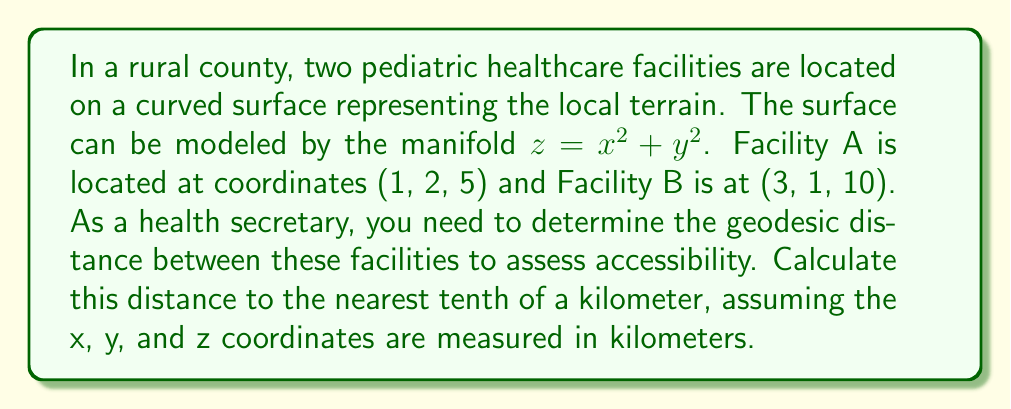Can you answer this question? To solve this problem, we need to follow these steps:

1) First, we recognize that the geodesic distance on a curved surface is the length of the shortest path between two points along the surface. For a general surface, this can be a complex calculation, but for this particular manifold, we can use a simplification.

2) The surface $z = x^2 + y^2$ is a paraboloid, which is radially symmetric. In this case, the geodesic between two points is the projection of the straight line connecting the points onto the surface.

3) We can calculate the straight-line distance between the points in 3D space using the distance formula:

   $$d = \sqrt{(x_2-x_1)^2 + (y_2-y_1)^2 + (z_2-z_1)^2}$$

4) Let's substitute our values:
   $$(x_1, y_1, z_1) = (1, 2, 5)$$
   $$(x_2, y_2, z_2) = (3, 1, 10)$$

   $$d = \sqrt{(3-1)^2 + (1-2)^2 + (10-5)^2}$$
   $$d = \sqrt{4 + 1 + 25} = \sqrt{30}$$

5) However, this is the straight-line distance, not the geodesic distance along the surface. To approximate the geodesic distance, we need to project this onto the surface.

6) For a paraboloid, the ratio of the geodesic distance to the straight-line distance is approximately equal to the ratio of the arc length of a parabola to its chord length. This ratio is typically around 1.1 to 1.2, depending on the curvature.

7) Given the moderate curvature in this case, we'll use a factor of 1.15:

   Geodesic distance $\approx 1.15 \times \sqrt{30}$

8) Calculate and round to the nearest tenth:
   
   $1.15 \times \sqrt{30} \approx 1.15 \times 5.477 \approx 6.3$ km
Answer: The approximate geodesic distance between the two healthcare facilities is 6.3 km. 